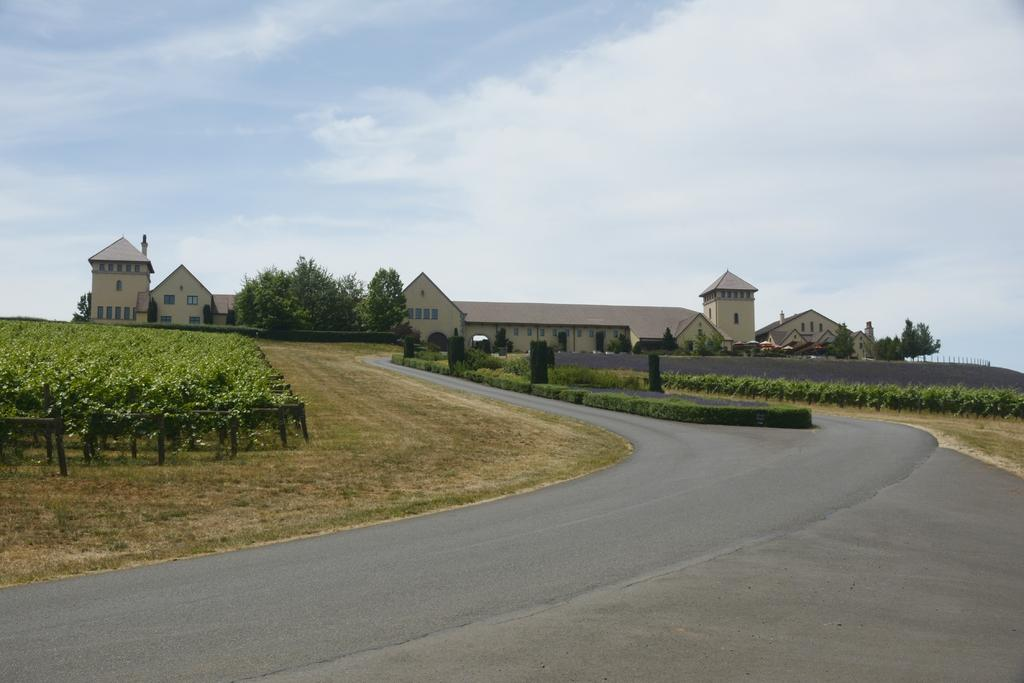What is the main feature of the image? There is a road in the image. What can be seen on the left side of the image? There are plants on the left side of the image. What can be seen on the right side of the image? There are plants on the right side of the image. What is visible in the background of the image? There is a building and trees in the background of the image. What is visible in the sky at the top of the image? There are clouds visible in the sky at the top of the image. Can you tell me how many requests were made during the birth depicted in the image? There is no depiction of a birth or any requests in the image; it features a road with plants on both sides, a building and trees in the background, and clouds in the sky. 